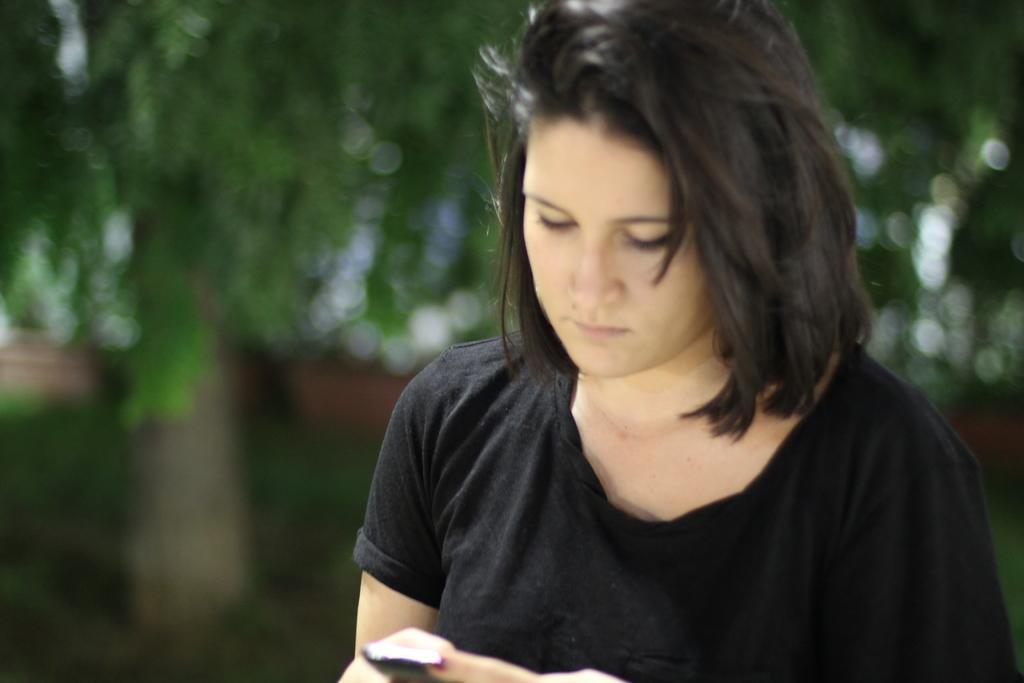Please provide a concise description of this image. In this image I can see a woman is holding the phone and looking into that, she wore blue color t-shirt. At the back side there are trees. 